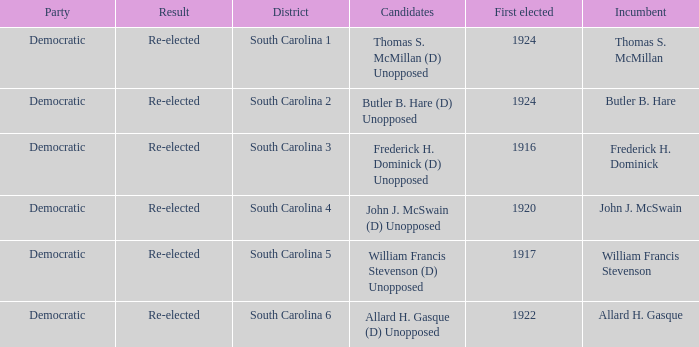Who is the candidate in district south carolina 2? Butler B. Hare (D) Unopposed. 